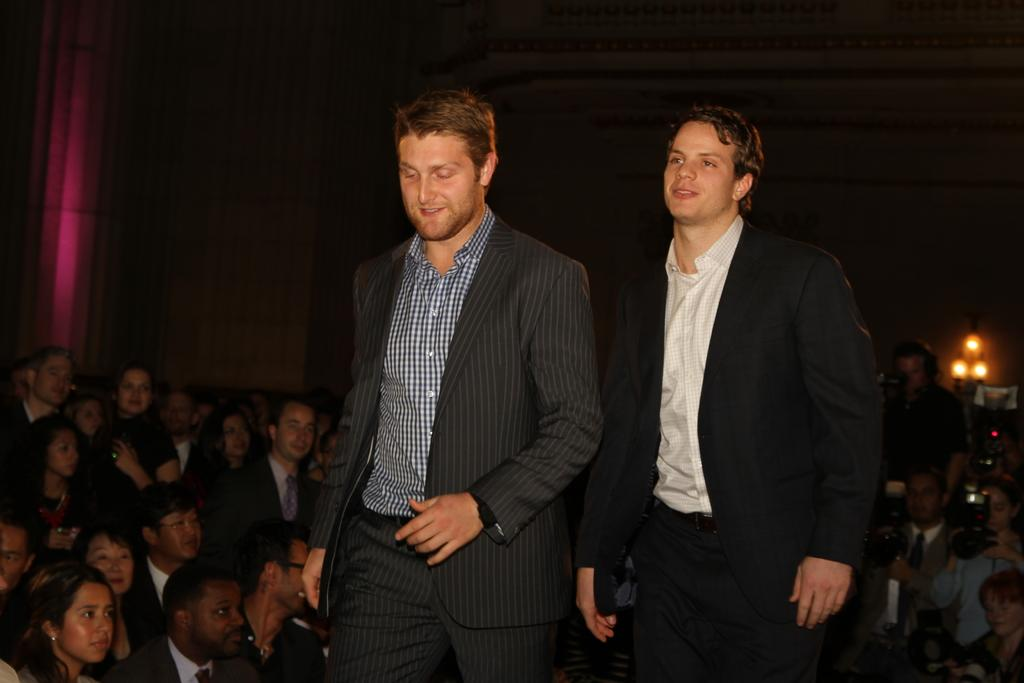How many people are present in the image? There are two people in the image. What are the two people wearing? The two people are wearing suits. What are the two people doing in the image? The two people are walking. What can be seen in the background of the image? There are people sitting on chairs and some people taking photos in the background of the image. Can you tell me where the cork is located in the image? There is no cork present in the image. What type of stamp can be seen on the suits of the two people? There are no stamps visible on the suits of the two people in the image. 